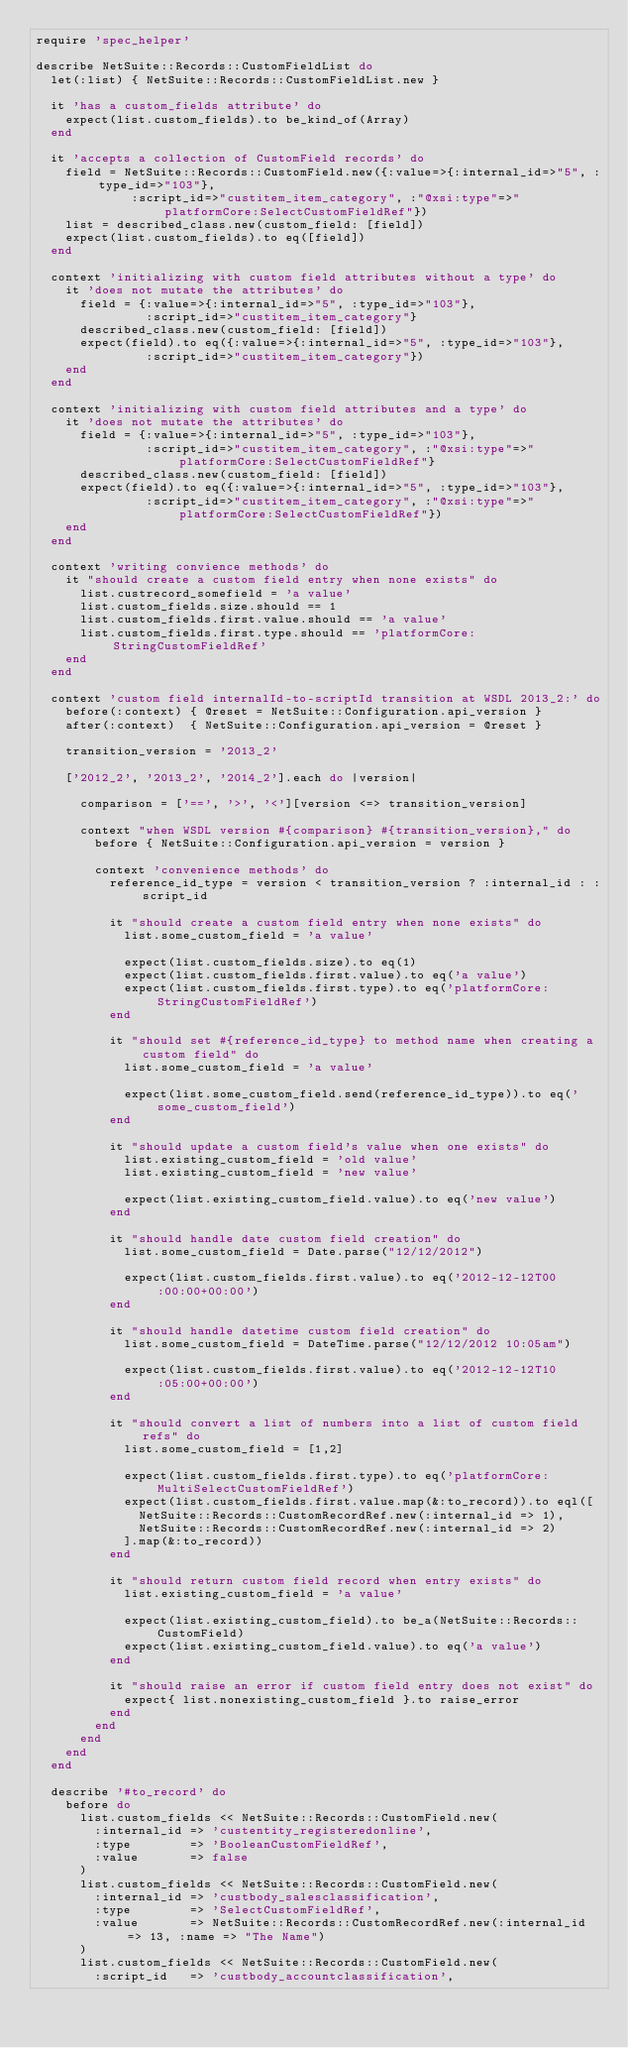<code> <loc_0><loc_0><loc_500><loc_500><_Ruby_>require 'spec_helper'

describe NetSuite::Records::CustomFieldList do
  let(:list) { NetSuite::Records::CustomFieldList.new }

  it 'has a custom_fields attribute' do
    expect(list.custom_fields).to be_kind_of(Array)
  end
  
  it 'accepts a collection of CustomField records' do
    field = NetSuite::Records::CustomField.new({:value=>{:internal_id=>"5", :type_id=>"103"},
             :script_id=>"custitem_item_category", :"@xsi:type"=>"platformCore:SelectCustomFieldRef"})
    list = described_class.new(custom_field: [field])
    expect(list.custom_fields).to eq([field])
  end

  context 'initializing with custom field attributes without a type' do
    it 'does not mutate the attributes' do
      field = {:value=>{:internal_id=>"5", :type_id=>"103"},
               :script_id=>"custitem_item_category"}
      described_class.new(custom_field: [field])
      expect(field).to eq({:value=>{:internal_id=>"5", :type_id=>"103"},
               :script_id=>"custitem_item_category"})
    end
  end

  context 'initializing with custom field attributes and a type' do
    it 'does not mutate the attributes' do
      field = {:value=>{:internal_id=>"5", :type_id=>"103"},
               :script_id=>"custitem_item_category", :"@xsi:type"=>"platformCore:SelectCustomFieldRef"}
      described_class.new(custom_field: [field])
      expect(field).to eq({:value=>{:internal_id=>"5", :type_id=>"103"},
               :script_id=>"custitem_item_category", :"@xsi:type"=>"platformCore:SelectCustomFieldRef"})
    end
  end

  context 'writing convience methods' do
    it "should create a custom field entry when none exists" do
      list.custrecord_somefield = 'a value'
      list.custom_fields.size.should == 1
      list.custom_fields.first.value.should == 'a value'
      list.custom_fields.first.type.should == 'platformCore:StringCustomFieldRef'
    end
  end

  context 'custom field internalId-to-scriptId transition at WSDL 2013_2:' do
    before(:context) { @reset = NetSuite::Configuration.api_version }
    after(:context)  { NetSuite::Configuration.api_version = @reset }

    transition_version = '2013_2'

    ['2012_2', '2013_2', '2014_2'].each do |version|

      comparison = ['==', '>', '<'][version <=> transition_version]

      context "when WSDL version #{comparison} #{transition_version}," do
        before { NetSuite::Configuration.api_version = version }

        context 'convenience methods' do
          reference_id_type = version < transition_version ? :internal_id : :script_id

          it "should create a custom field entry when none exists" do
            list.some_custom_field = 'a value'

            expect(list.custom_fields.size).to eq(1)
            expect(list.custom_fields.first.value).to eq('a value')
            expect(list.custom_fields.first.type).to eq('platformCore:StringCustomFieldRef')
          end

          it "should set #{reference_id_type} to method name when creating a custom field" do
            list.some_custom_field = 'a value'

            expect(list.some_custom_field.send(reference_id_type)).to eq('some_custom_field')
          end

          it "should update a custom field's value when one exists" do
            list.existing_custom_field = 'old value'
            list.existing_custom_field = 'new value'

            expect(list.existing_custom_field.value).to eq('new value')
          end

          it "should handle date custom field creation" do
            list.some_custom_field = Date.parse("12/12/2012")

            expect(list.custom_fields.first.value).to eq('2012-12-12T00:00:00+00:00')
          end

          it "should handle datetime custom field creation" do
            list.some_custom_field = DateTime.parse("12/12/2012 10:05am")

            expect(list.custom_fields.first.value).to eq('2012-12-12T10:05:00+00:00')
          end

          it "should convert a list of numbers into a list of custom field refs" do
            list.some_custom_field = [1,2]

            expect(list.custom_fields.first.type).to eq('platformCore:MultiSelectCustomFieldRef')
            expect(list.custom_fields.first.value.map(&:to_record)).to eql([
              NetSuite::Records::CustomRecordRef.new(:internal_id => 1),
              NetSuite::Records::CustomRecordRef.new(:internal_id => 2)
            ].map(&:to_record))
          end

          it "should return custom field record when entry exists" do
            list.existing_custom_field = 'a value'

            expect(list.existing_custom_field).to be_a(NetSuite::Records::CustomField)
            expect(list.existing_custom_field.value).to eq('a value')
          end

          it "should raise an error if custom field entry does not exist" do
            expect{ list.nonexisting_custom_field }.to raise_error
          end
        end
      end
    end
  end

  describe '#to_record' do
    before do
      list.custom_fields << NetSuite::Records::CustomField.new(
        :internal_id => 'custentity_registeredonline',
        :type        => 'BooleanCustomFieldRef',
        :value       => false
      )
      list.custom_fields << NetSuite::Records::CustomField.new(
        :internal_id => 'custbody_salesclassification',
        :type        => 'SelectCustomFieldRef',
        :value       => NetSuite::Records::CustomRecordRef.new(:internal_id => 13, :name => "The Name")
      )
      list.custom_fields << NetSuite::Records::CustomField.new(
        :script_id   => 'custbody_accountclassification',</code> 